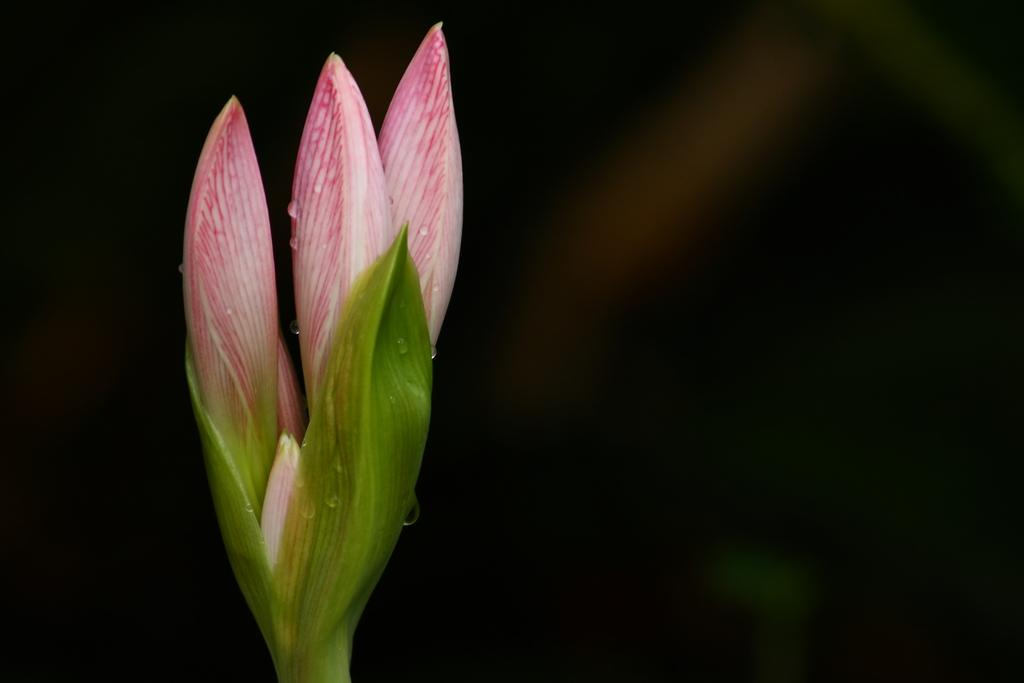How many flower buds are visible in the image? There are three flower buds in the image. What can be observed about the background of the image? The background of the image is dark. What type of ticket is required to enter the territory depicted in the image? There is no territory or ticket mentioned in the image; it only features three flower buds against a dark background. 